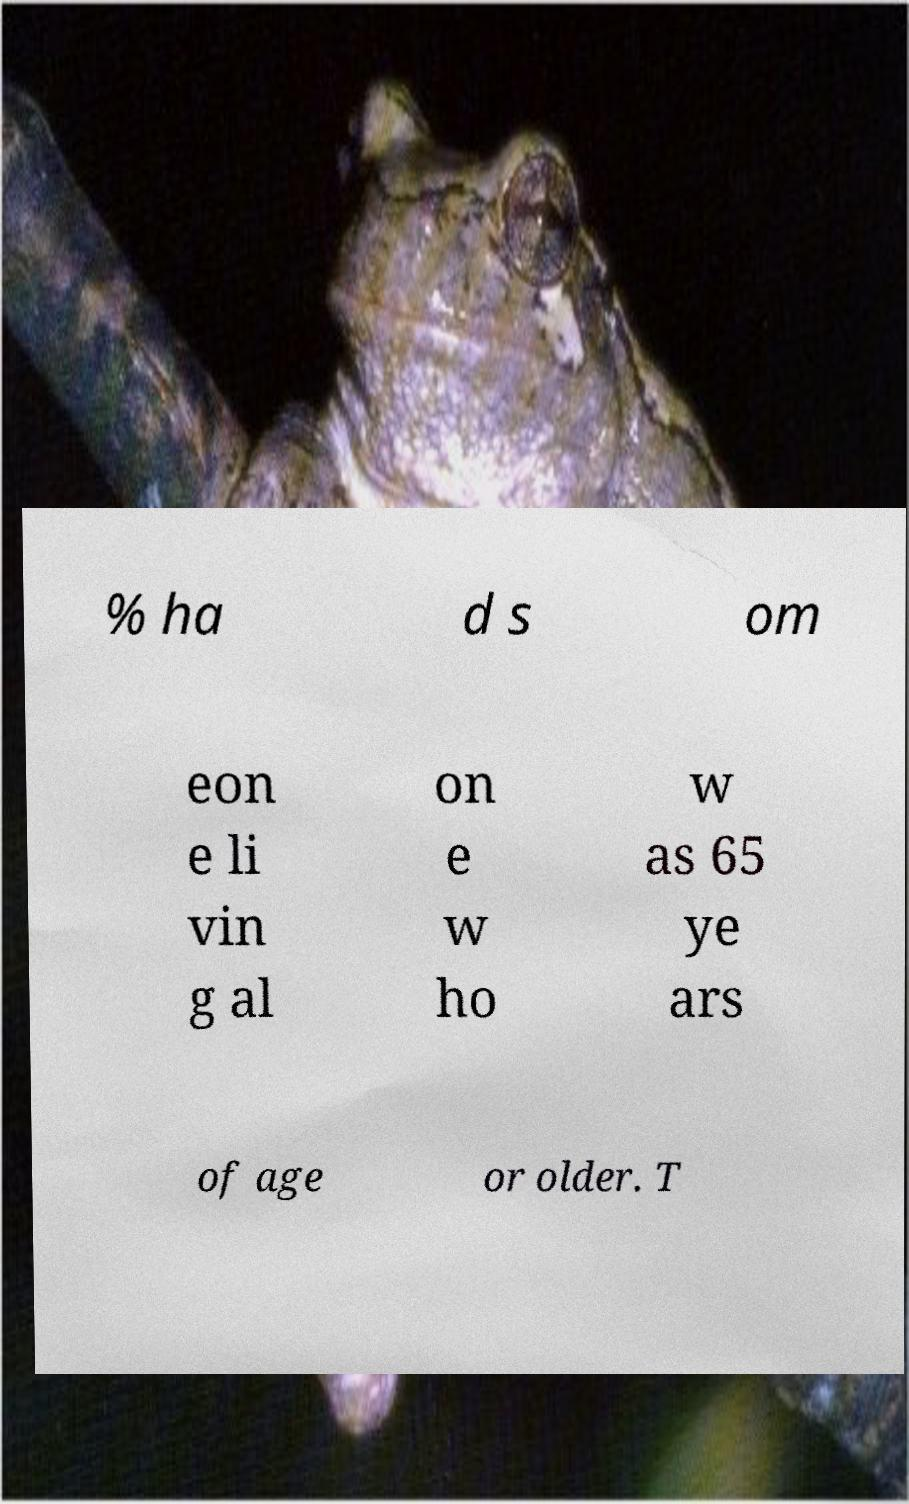Could you extract and type out the text from this image? % ha d s om eon e li vin g al on e w ho w as 65 ye ars of age or older. T 